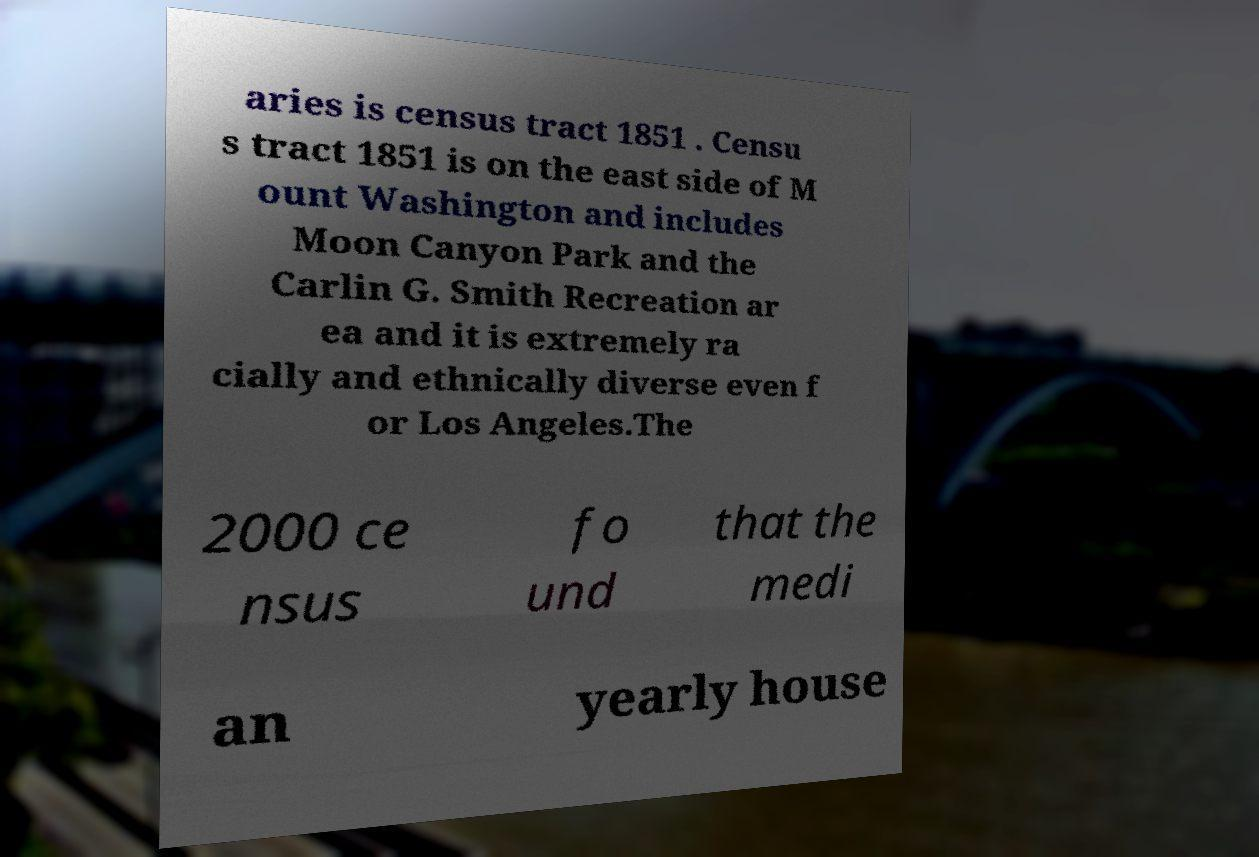Can you accurately transcribe the text from the provided image for me? aries is census tract 1851 . Censu s tract 1851 is on the east side of M ount Washington and includes Moon Canyon Park and the Carlin G. Smith Recreation ar ea and it is extremely ra cially and ethnically diverse even f or Los Angeles.The 2000 ce nsus fo und that the medi an yearly house 